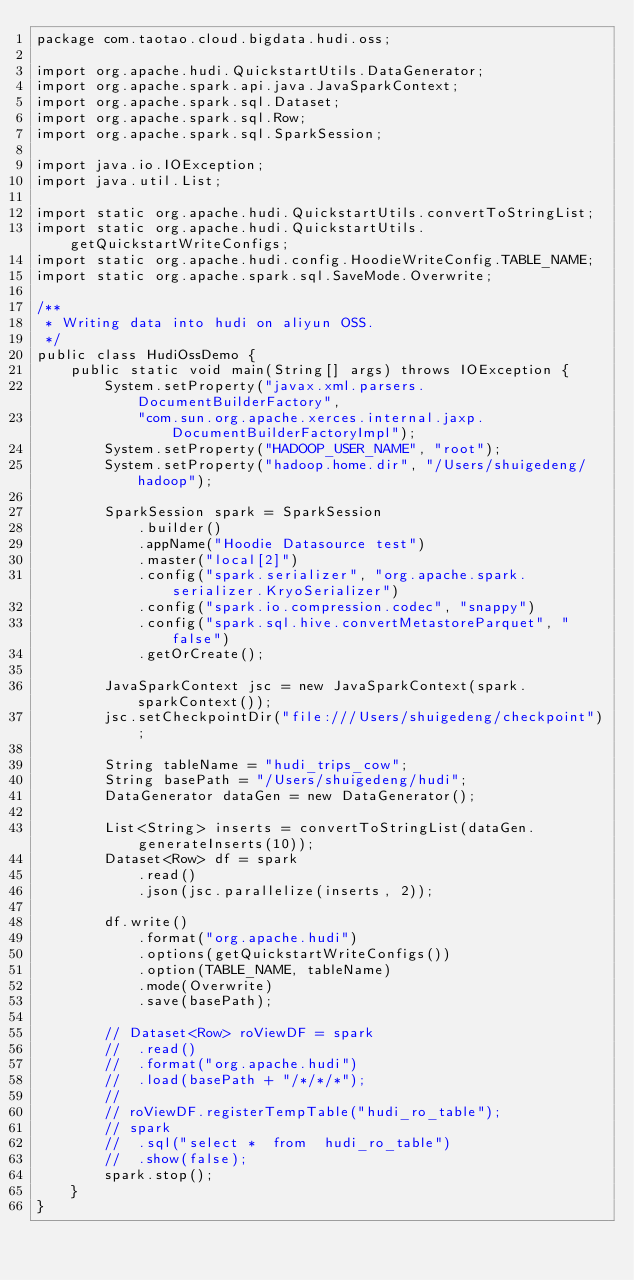<code> <loc_0><loc_0><loc_500><loc_500><_Java_>package com.taotao.cloud.bigdata.hudi.oss;

import org.apache.hudi.QuickstartUtils.DataGenerator;
import org.apache.spark.api.java.JavaSparkContext;
import org.apache.spark.sql.Dataset;
import org.apache.spark.sql.Row;
import org.apache.spark.sql.SparkSession;

import java.io.IOException;
import java.util.List;

import static org.apache.hudi.QuickstartUtils.convertToStringList;
import static org.apache.hudi.QuickstartUtils.getQuickstartWriteConfigs;
import static org.apache.hudi.config.HoodieWriteConfig.TABLE_NAME;
import static org.apache.spark.sql.SaveMode.Overwrite;

/**
 * Writing data into hudi on aliyun OSS.
 */
public class HudiOssDemo {
	public static void main(String[] args) throws IOException {
		System.setProperty("javax.xml.parsers.DocumentBuilderFactory",
			"com.sun.org.apache.xerces.internal.jaxp.DocumentBuilderFactoryImpl");
		System.setProperty("HADOOP_USER_NAME", "root");
		System.setProperty("hadoop.home.dir", "/Users/shuigedeng/hadoop");

		SparkSession spark = SparkSession
			.builder()
			.appName("Hoodie Datasource test")
			.master("local[2]")
			.config("spark.serializer", "org.apache.spark.serializer.KryoSerializer")
			.config("spark.io.compression.codec", "snappy")
			.config("spark.sql.hive.convertMetastoreParquet", "false")
			.getOrCreate();

		JavaSparkContext jsc = new JavaSparkContext(spark.sparkContext());
		jsc.setCheckpointDir("file:///Users/shuigedeng/checkpoint");

		String tableName = "hudi_trips_cow";
		String basePath = "/Users/shuigedeng/hudi";
		DataGenerator dataGen = new DataGenerator();

		List<String> inserts = convertToStringList(dataGen.generateInserts(10));
		Dataset<Row> df = spark
			.read()
			.json(jsc.parallelize(inserts, 2));

		df.write()
			.format("org.apache.hudi")
			.options(getQuickstartWriteConfigs())
			.option(TABLE_NAME, tableName)
			.mode(Overwrite)
			.save(basePath);

		// Dataset<Row> roViewDF = spark
		// 	.read()
		// 	.format("org.apache.hudi")
		// 	.load(basePath + "/*/*/*");
		//
		// roViewDF.registerTempTable("hudi_ro_table");
		// spark
		// 	.sql("select *  from  hudi_ro_table")
		// 	.show(false);
		spark.stop();
	}
}
</code> 